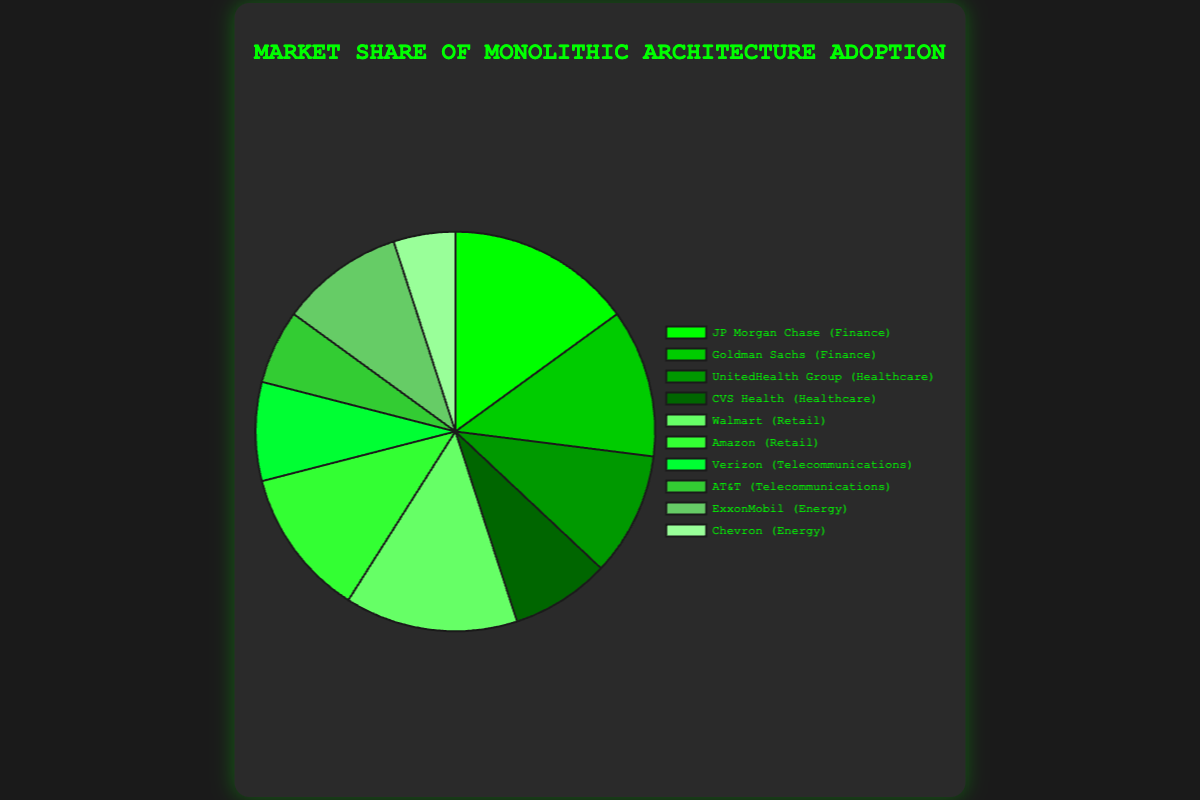Which company has the highest market share in the Finance industry? In the Finance industry, the two companies shown are JP Morgan Chase with a 15% market share and Goldman Sachs with a 12% market share. JP Morgan Chase has the highest market share.
Answer: JP Morgan Chase What is the combined market share percentage of the Healthcare industry? The Healthcare industry consists of UnitedHealth Group with a 10% market share and CVS Health with an 8% market share. Adding these two percentages gives 10% + 8% = 18%.
Answer: 18% Which industry has a greater total market share, Retail or Telecommunications? In Retail, Walmart has a 14% market share, and Amazon has 12%. Their combined share is 14% + 12% = 26%. In Telecommunications, Verizon has 8%, and AT&T has 6%. Their combined share is 8% + 6% = 14%. Therefore, Retail has a greater total market share than Telecommunications.
Answer: Retail What is the difference in market share percentage between Walmart and Chevron? Walmart has a market share of 14%, and Chevron has a market share of 5%. The difference is 14% - 5% = 9%.
Answer: 9% Which industry has the smallest total market share, and what is it? In Telecommunications, Verizon has an 8% market share, and AT&T has 6%, totaling 14%. In Energy, ExxonMobil has 10%, and Chevron has 5%, totaling 15%. Healthcare totals 18%, Finance totals 27%, and Retail totals 26%. Hence, Telecommunications has the smallest total market share of 14%.
Answer: Telecommunications, 14% There are four slices in varying shades of green. Which company corresponds to the darkest shade of green and what is its market share? The darkest shade usually represents the first color in a typical pie chart's color sequence. JP Morgan Chase, which has the highest market share segment in Finance (15%), fits this description.
Answer: JP Morgan Chase, 15% What's the average market share percentage across all companies? Adding the market share percentages for all companies gives 15 + 12 + 10 + 8 + 14 + 12 + 8 + 6 + 10 + 5 = 100. There are 10 companies, so the average is 100/10 = 10%.
Answer: 10% How does the market share of JP Morgan Chase compare to that of UnitedHealth Group? JP Morgan Chase has a market share of 15%, while UnitedHealth Group has 10%. Therefore, JP Morgan Chase's market share is greater by 15% - 10% = 5%.
Answer: JP Morgan Chase has 5% more What's the total market share percentage of companies in the Finance and Energy industries combined? In the Finance industry, JP Morgan Chase has 15% and Goldman Sachs has 12%, totaling 27%. In the Energy industry, ExxonMobil has 10% and Chevron has 5%, totaling 15%. Combined, this is 27% + 15% = 42%.
Answer: 42% Which of the two, Amazon or UnitedHealth Group, has a higher market share, and by how much? Amazon has a 12% market share, and UnitedHealth Group has 10%. Amazon's market share is higher by 12% - 10% = 2%.
Answer: Amazon by 2% 